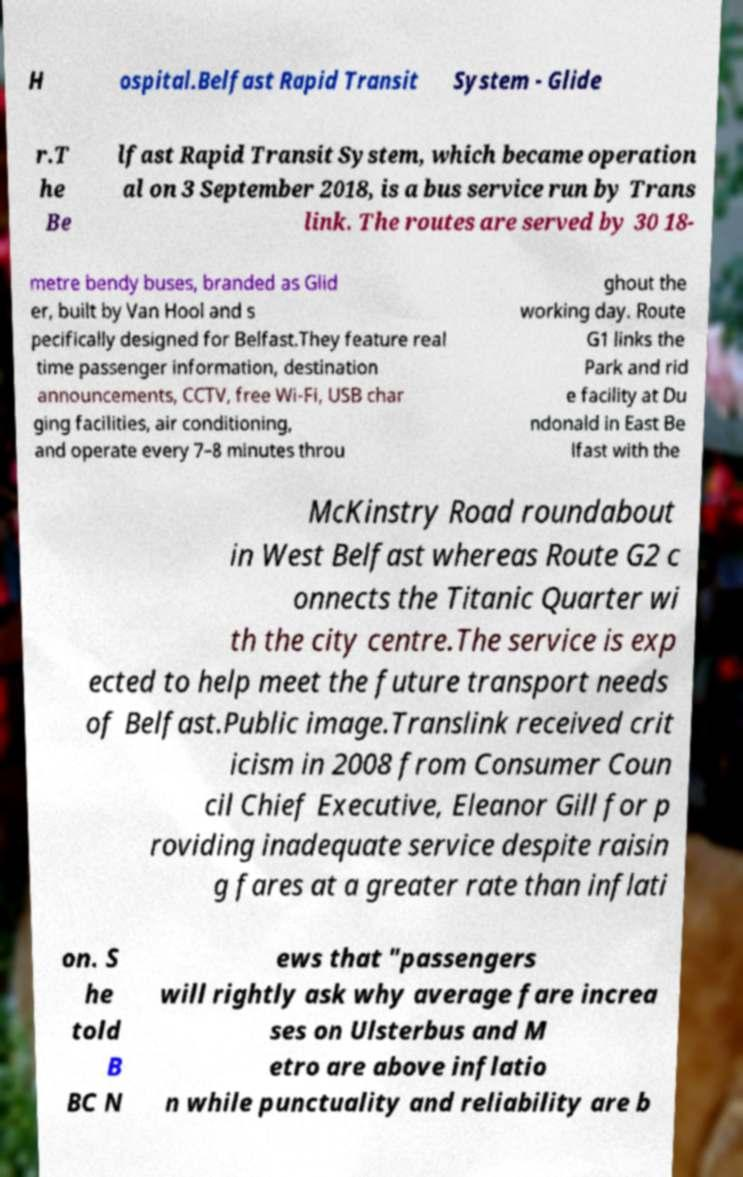What messages or text are displayed in this image? I need them in a readable, typed format. H ospital.Belfast Rapid Transit System - Glide r.T he Be lfast Rapid Transit System, which became operation al on 3 September 2018, is a bus service run by Trans link. The routes are served by 30 18- metre bendy buses, branded as Glid er, built by Van Hool and s pecifically designed for Belfast.They feature real time passenger information, destination announcements, CCTV, free Wi-Fi, USB char ging facilities, air conditioning, and operate every 7–8 minutes throu ghout the working day. Route G1 links the Park and rid e facility at Du ndonald in East Be lfast with the McKinstry Road roundabout in West Belfast whereas Route G2 c onnects the Titanic Quarter wi th the city centre.The service is exp ected to help meet the future transport needs of Belfast.Public image.Translink received crit icism in 2008 from Consumer Coun cil Chief Executive, Eleanor Gill for p roviding inadequate service despite raisin g fares at a greater rate than inflati on. S he told B BC N ews that "passengers will rightly ask why average fare increa ses on Ulsterbus and M etro are above inflatio n while punctuality and reliability are b 